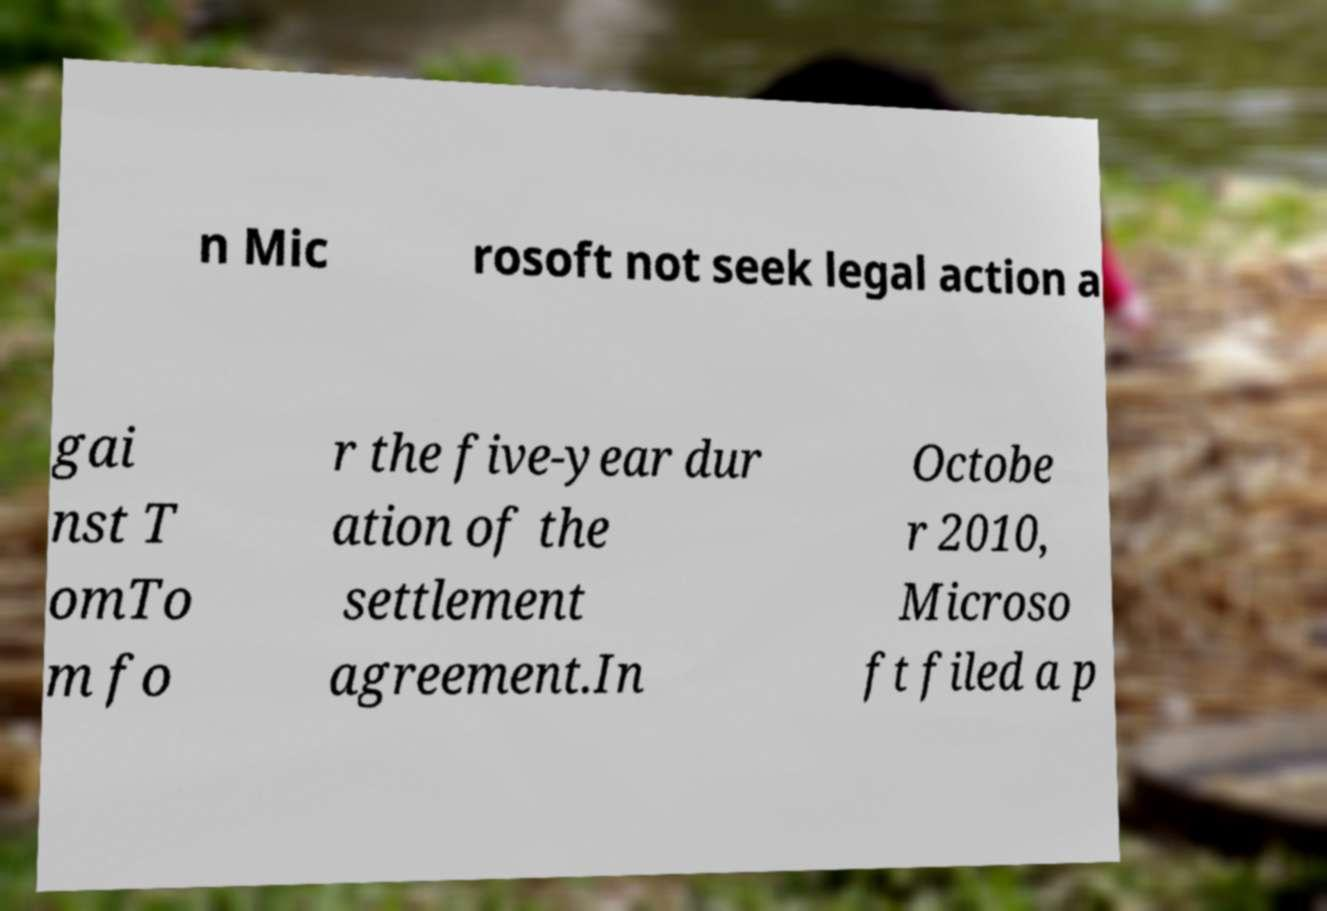What messages or text are displayed in this image? I need them in a readable, typed format. n Mic rosoft not seek legal action a gai nst T omTo m fo r the five-year dur ation of the settlement agreement.In Octobe r 2010, Microso ft filed a p 